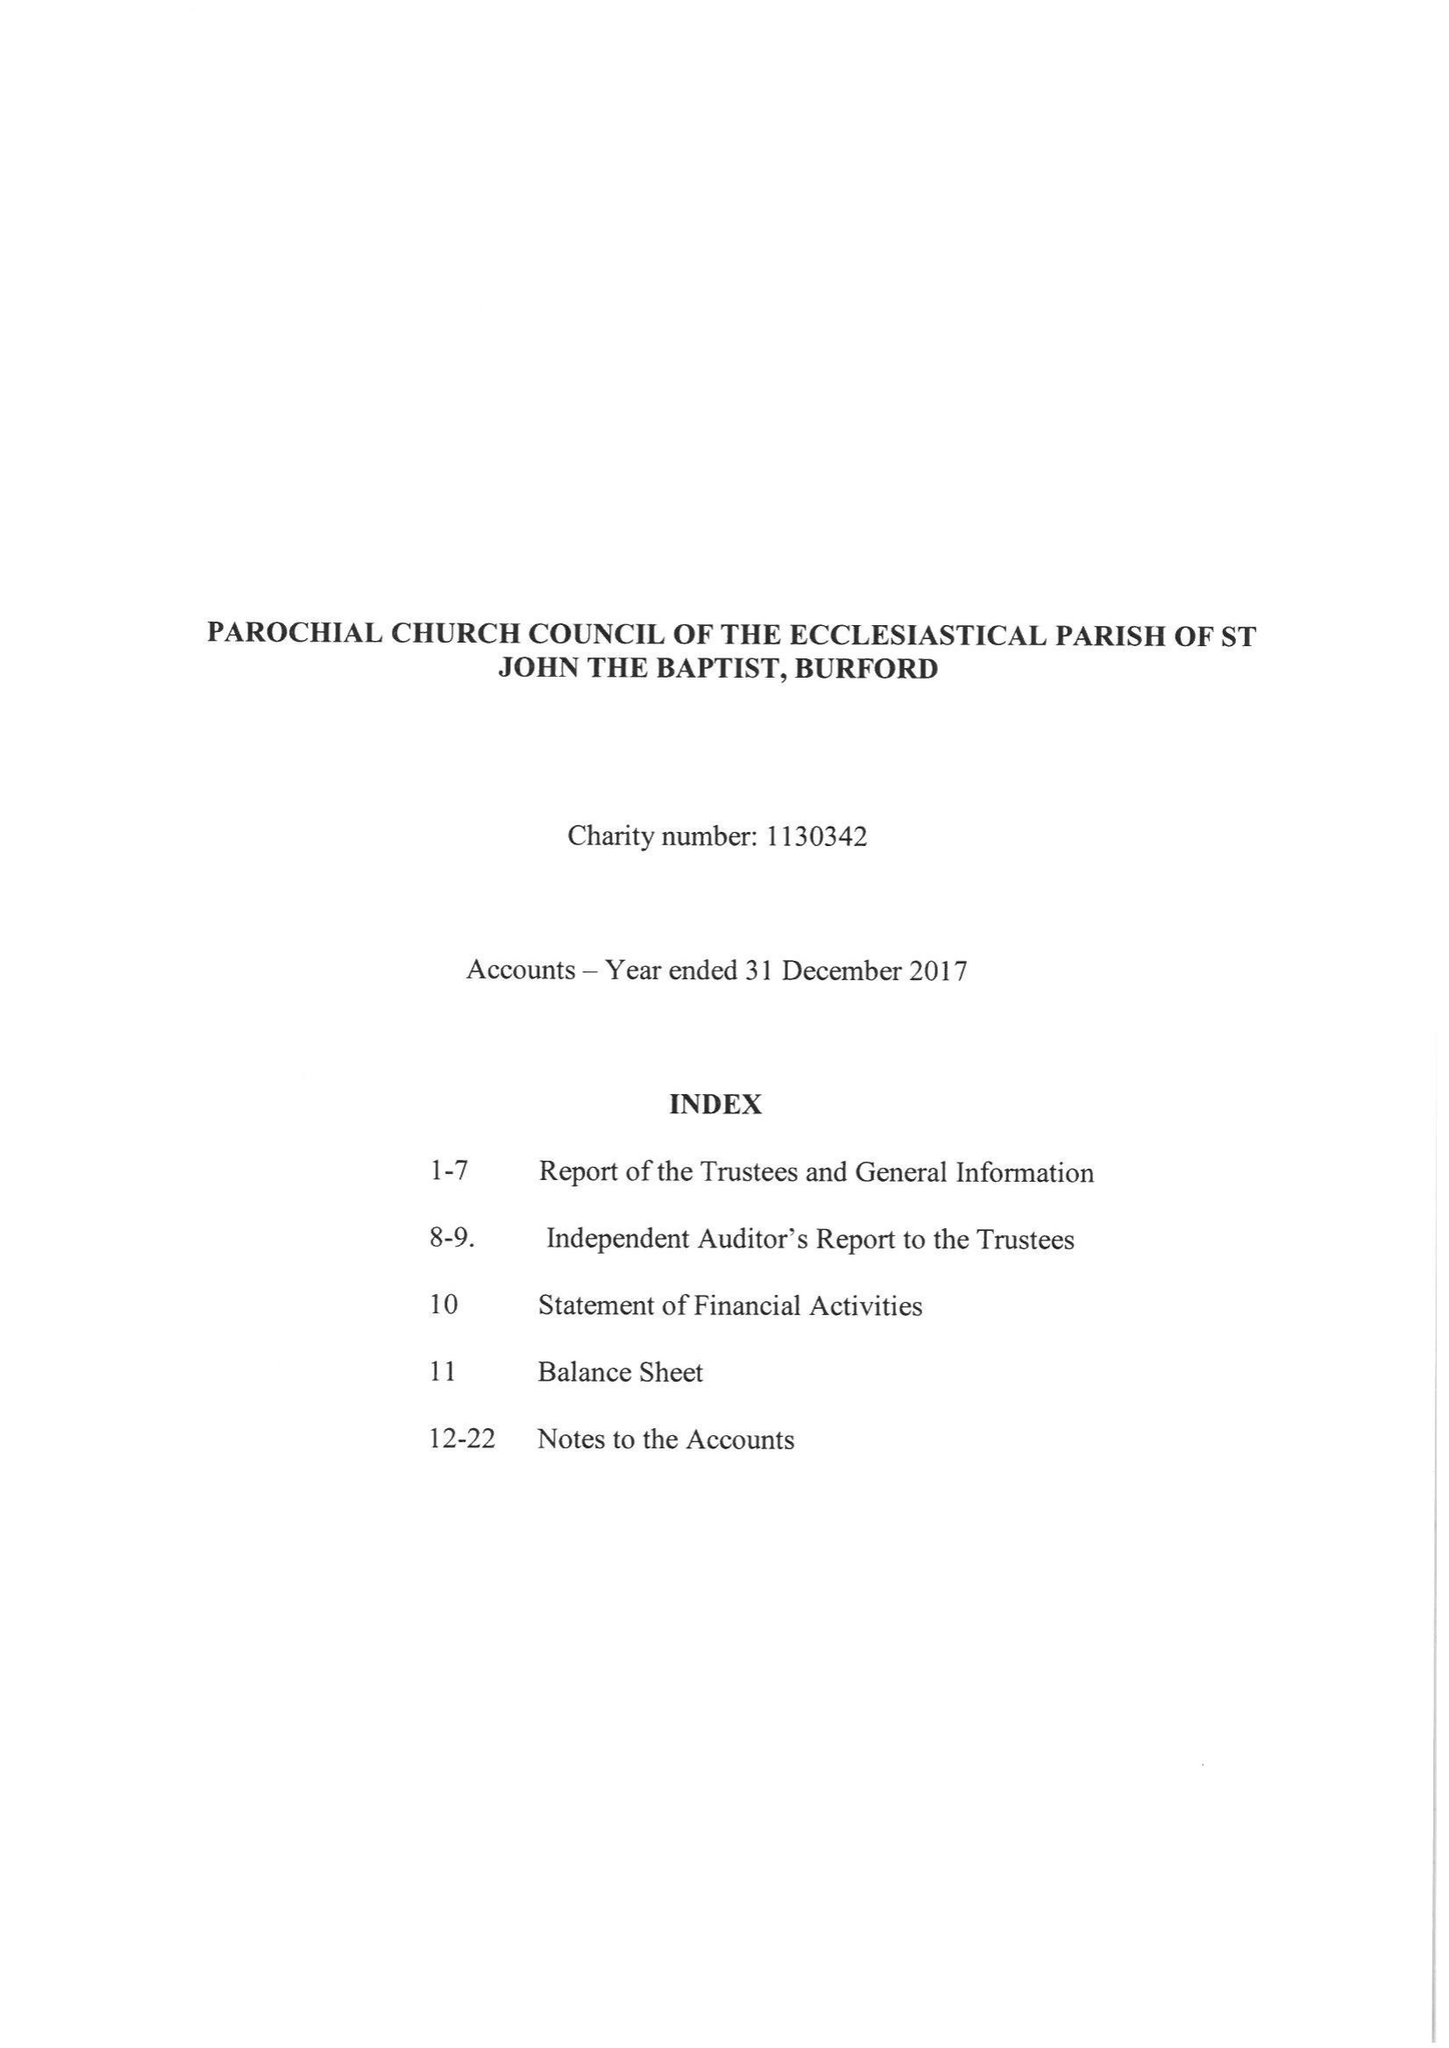What is the value for the address__street_line?
Answer the question using a single word or phrase. CHURCH GREEN 